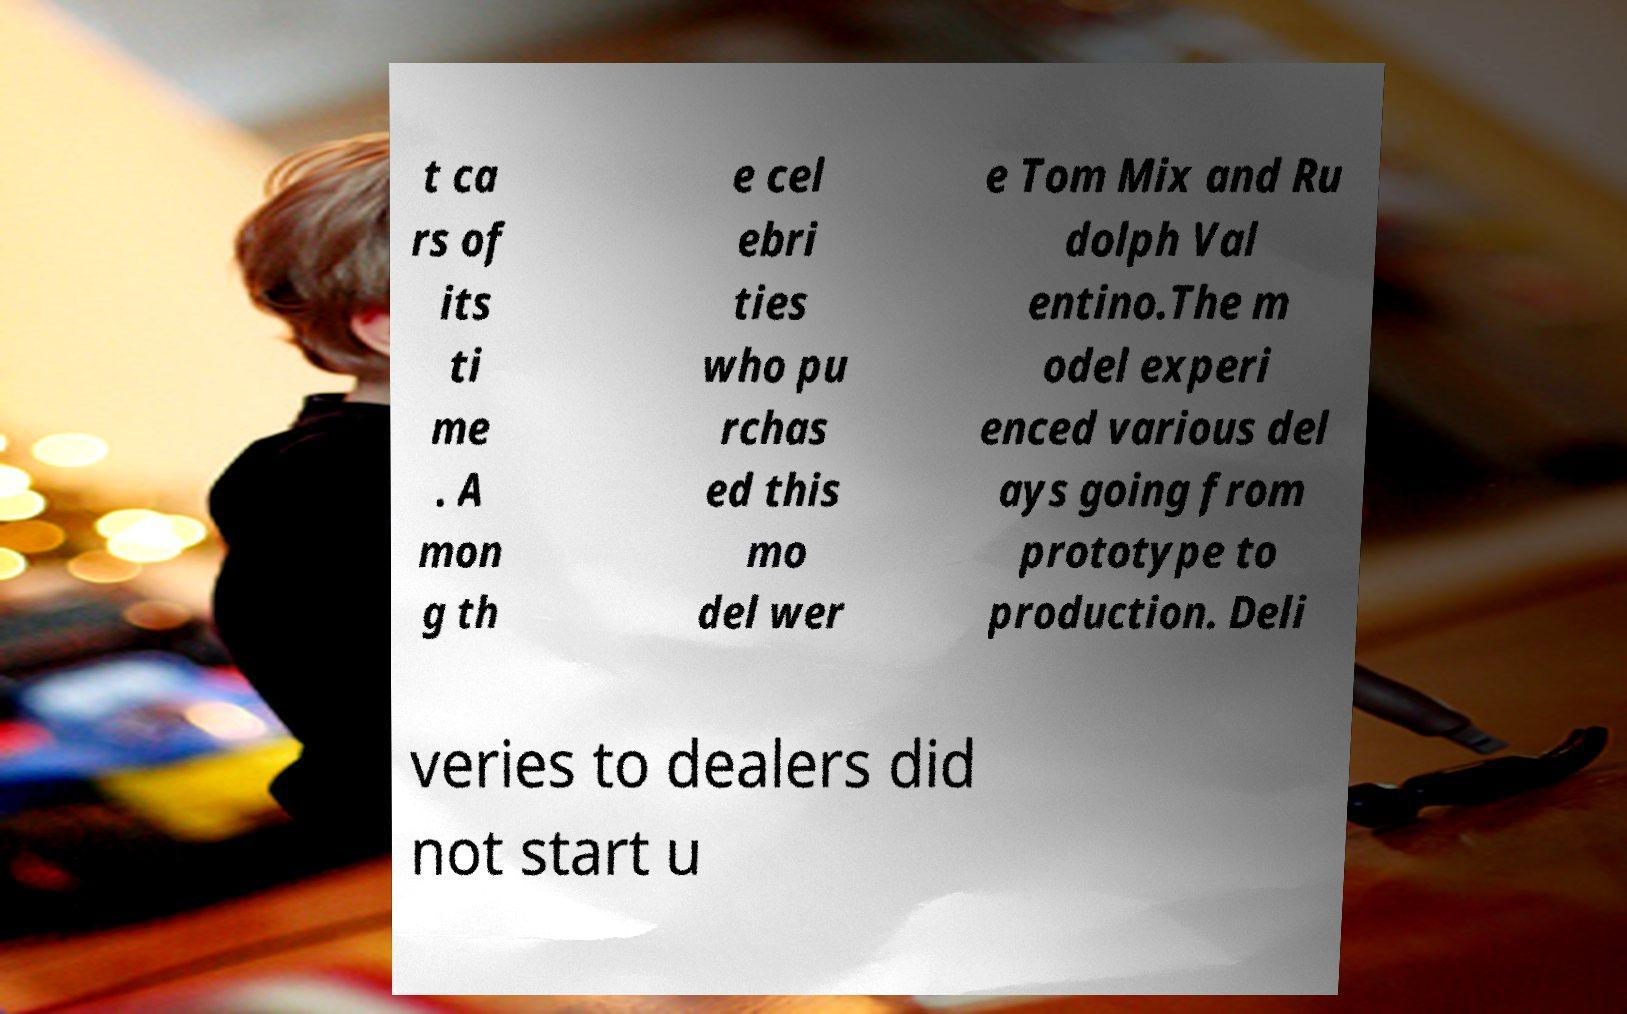I need the written content from this picture converted into text. Can you do that? t ca rs of its ti me . A mon g th e cel ebri ties who pu rchas ed this mo del wer e Tom Mix and Ru dolph Val entino.The m odel experi enced various del ays going from prototype to production. Deli veries to dealers did not start u 